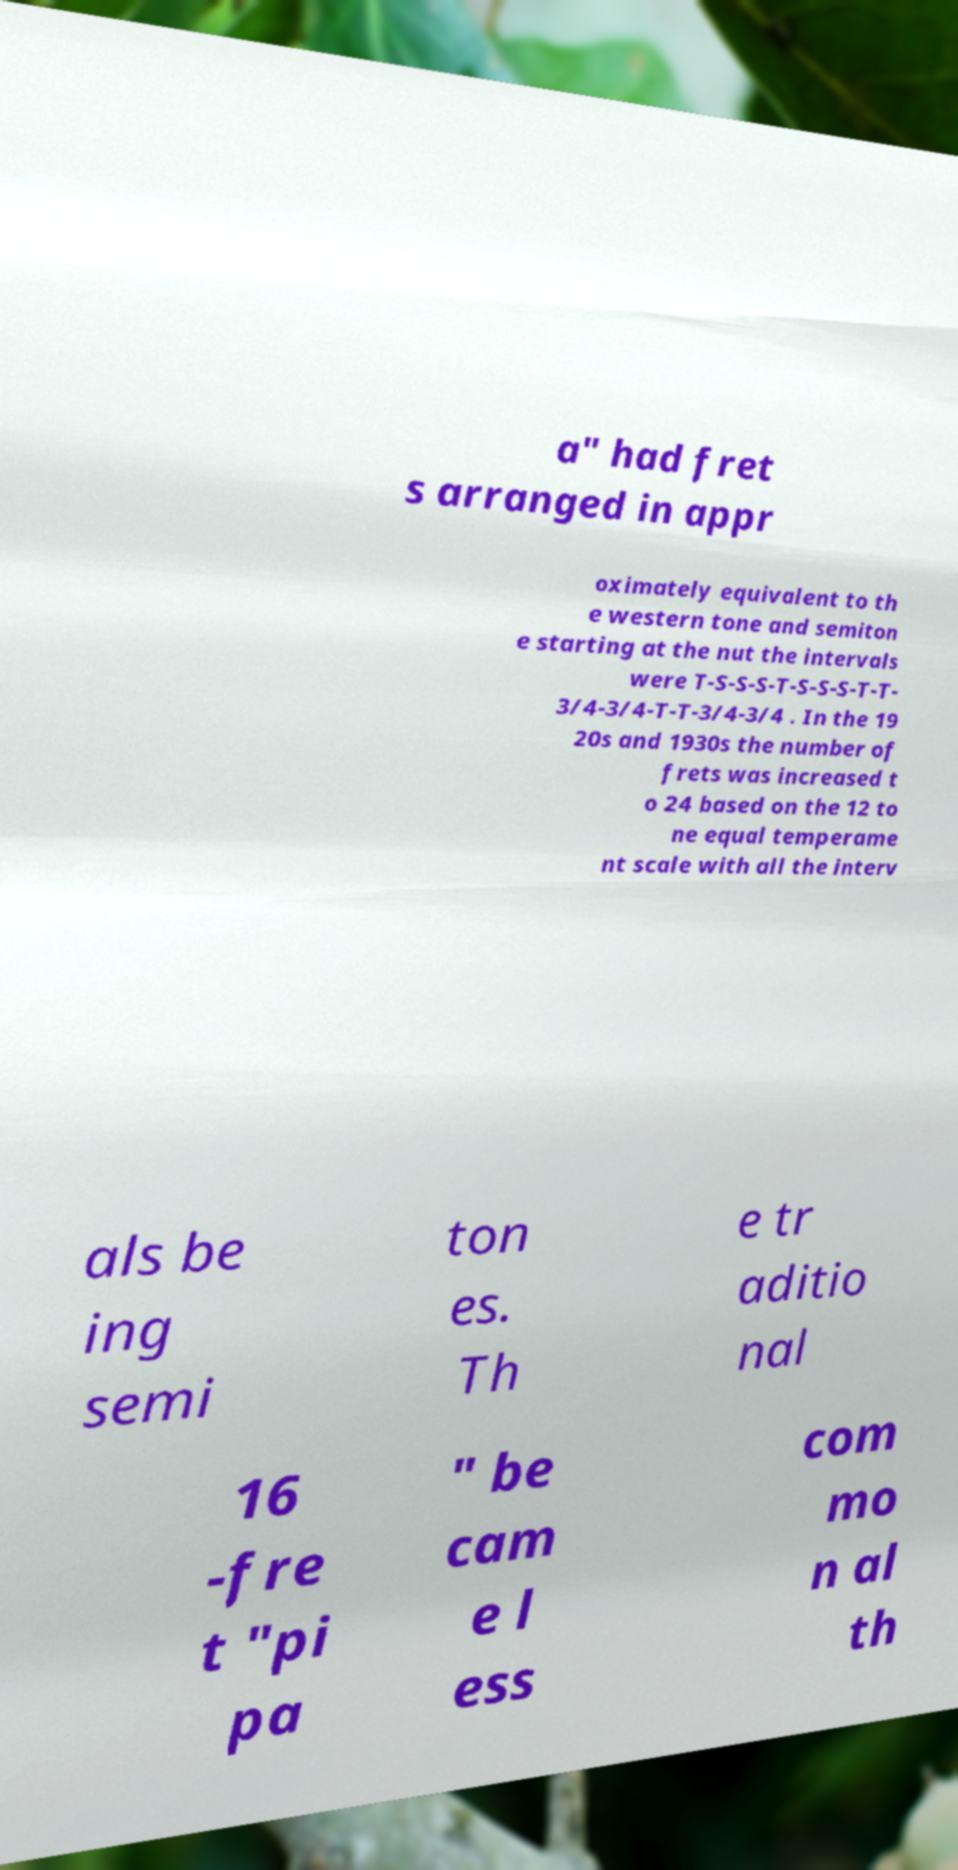There's text embedded in this image that I need extracted. Can you transcribe it verbatim? a" had fret s arranged in appr oximately equivalent to th e western tone and semiton e starting at the nut the intervals were T-S-S-S-T-S-S-S-T-T- 3/4-3/4-T-T-3/4-3/4 . In the 19 20s and 1930s the number of frets was increased t o 24 based on the 12 to ne equal temperame nt scale with all the interv als be ing semi ton es. Th e tr aditio nal 16 -fre t "pi pa " be cam e l ess com mo n al th 